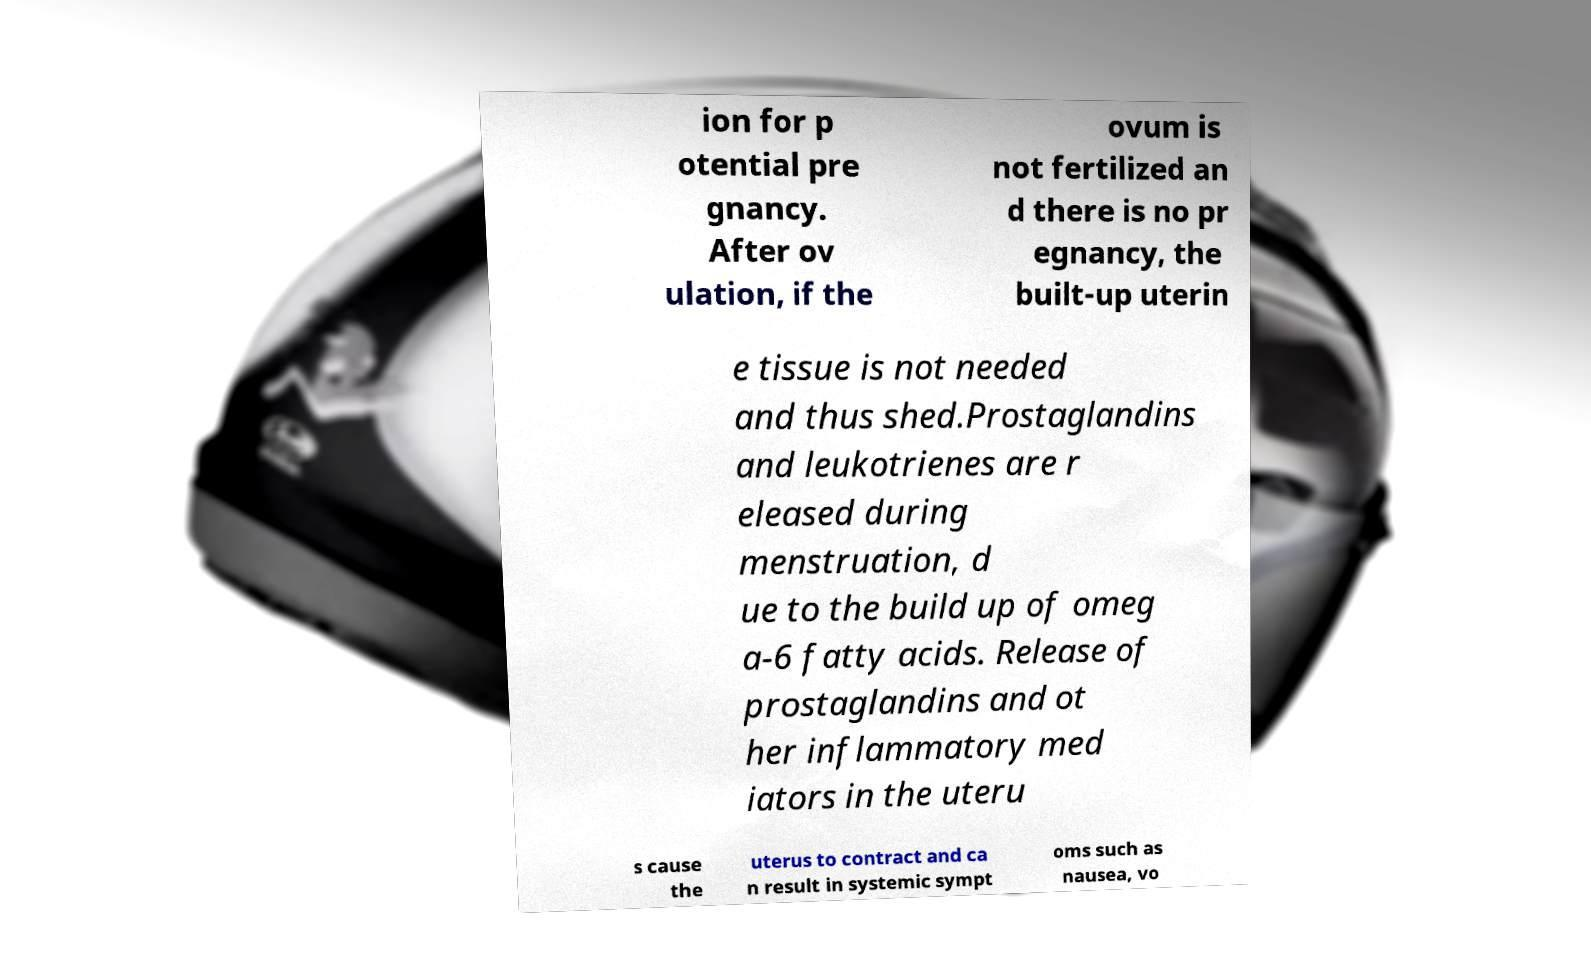Please identify and transcribe the text found in this image. ion for p otential pre gnancy. After ov ulation, if the ovum is not fertilized an d there is no pr egnancy, the built-up uterin e tissue is not needed and thus shed.Prostaglandins and leukotrienes are r eleased during menstruation, d ue to the build up of omeg a-6 fatty acids. Release of prostaglandins and ot her inflammatory med iators in the uteru s cause the uterus to contract and ca n result in systemic sympt oms such as nausea, vo 